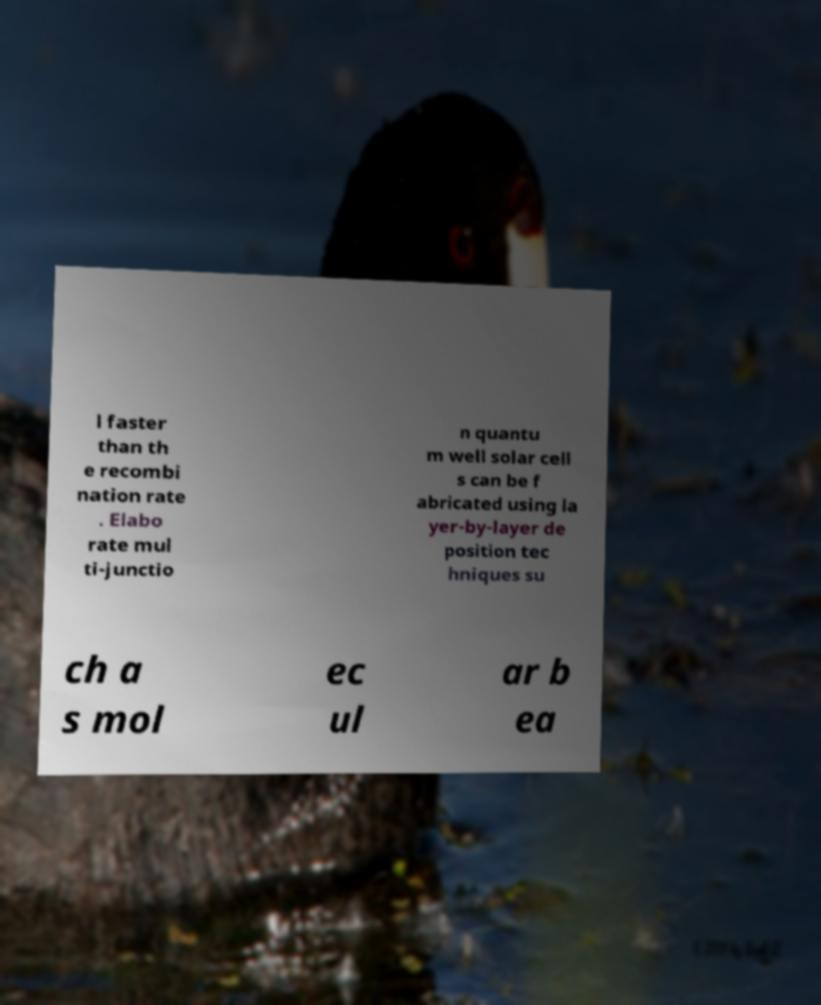Could you extract and type out the text from this image? l faster than th e recombi nation rate . Elabo rate mul ti-junctio n quantu m well solar cell s can be f abricated using la yer-by-layer de position tec hniques su ch a s mol ec ul ar b ea 